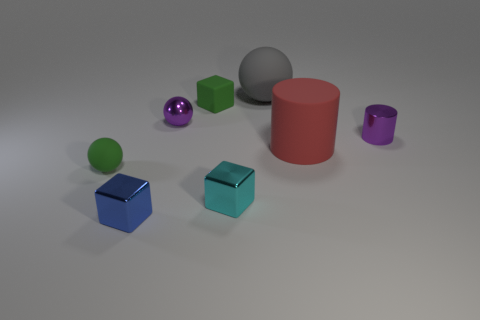There is a small purple thing on the left side of the cyan shiny block; what number of tiny blocks are in front of it?
Your answer should be compact. 2. Is the number of small green rubber cubes on the right side of the tiny blue object less than the number of big metallic things?
Provide a succinct answer. No. Are there any green spheres in front of the green matte object to the left of the block behind the small matte ball?
Your answer should be very brief. No. Is the material of the tiny blue thing the same as the small sphere right of the green ball?
Offer a terse response. Yes. What color is the shiny object right of the rubber ball that is right of the blue metal object?
Offer a very short reply. Purple. Is there a metal thing of the same color as the metal cylinder?
Your response must be concise. Yes. What size is the matte sphere behind the big rubber cylinder on the right side of the small rubber thing in front of the big cylinder?
Your answer should be very brief. Large. Is the shape of the blue object the same as the big object that is in front of the small purple cylinder?
Ensure brevity in your answer.  No. How many other objects are the same size as the cyan metal cube?
Offer a terse response. 5. There is a thing on the right side of the large red rubber thing; what is its size?
Give a very brief answer. Small. 